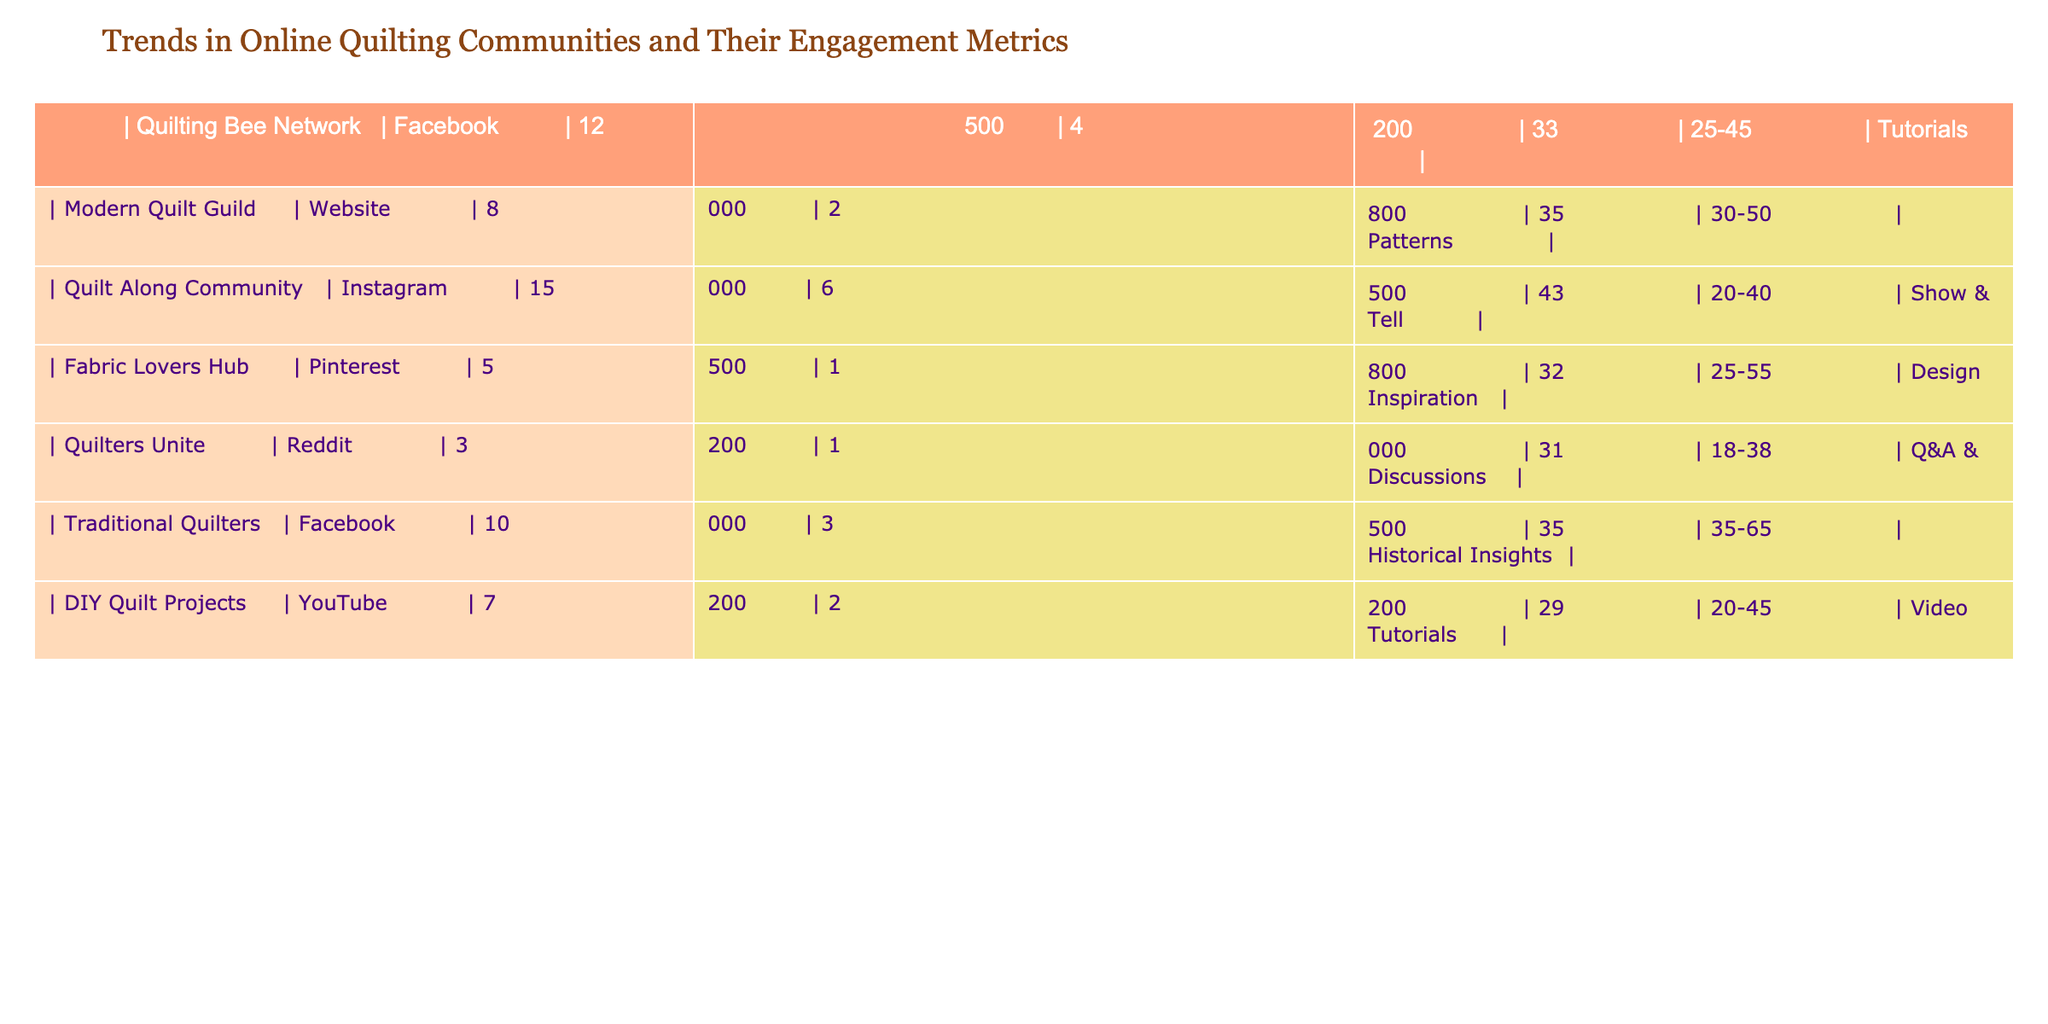What is the highest number of members in a quilting community? The data shows the number of members for each community. By reviewing the third column, the highest number is 15,000 from the Quilt Along Community.
Answer: 15,000 Which platform has the most engagement in terms of interactions? The engagement is determined by the number of interactions, noted in the fourth column. Comparing the values, the Quilt Along Community has the highest, at 6,500 interactions.
Answer: 6,500 What is the average age of members across all quilting communities? To find the average age, we add all the ages together: (33 + 35 + 43 + 32 + 31 + 35 + 29) = 238. There are 7 communities, so the average age is 238 / 7 = approximately 34.
Answer: 34 Is the Modern Quilt Guild the only community that provides patterns? Checking the last column for the pattern availability, Modern Quilt Guild is listed under patterns. However, no other community is noted for offering patterns, meaning it is indeed the only one.
Answer: Yes How many community members are from Facebook? By scanning the first column for communities using Facebook, we find two: Quilting Bee Network (12,500) and Traditional Quilters (10,000). Summing these gives us 12,500 + 10,000 = 22,500.
Answer: 22,500 Which community has the least number of interactions? The fourth column shows interactions, with the Quilters Unite community having the least at 1,000 interactions.
Answer: 1,000 Are there any communities with all members aged below 40? Looking at the age ranges in the column, the Quilt Along Community (20-40) and DIY Quilt Projects (20-45) have members aged below 40, which means there are indeed communities fitting that criteria.
Answer: Yes What percentage of members in traditional quilting are 45 or older? Traditional Quilters has members aged 35-65. To find the members aged 45 or older, we assume half the age range (35 to 65), representing approximately 50%. So, percentages of those aged 45+ can be at least 50% of the total 10,000 members, which equals around 5,000 members.
Answer: 5,000 